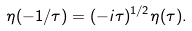Convert formula to latex. <formula><loc_0><loc_0><loc_500><loc_500>\eta ( - 1 / \tau ) = ( - i \tau ) ^ { 1 / 2 } \eta ( \tau ) .</formula> 